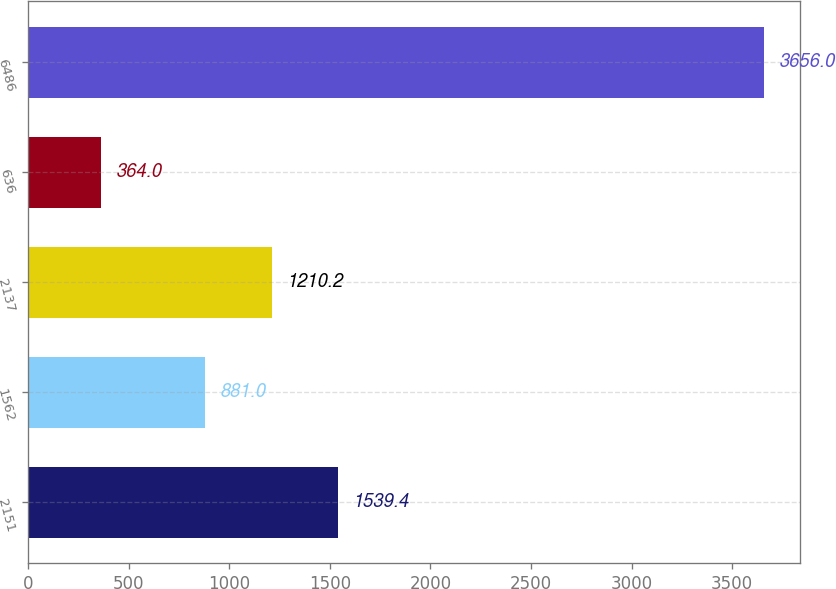<chart> <loc_0><loc_0><loc_500><loc_500><bar_chart><fcel>2151<fcel>1562<fcel>2137<fcel>636<fcel>6486<nl><fcel>1539.4<fcel>881<fcel>1210.2<fcel>364<fcel>3656<nl></chart> 